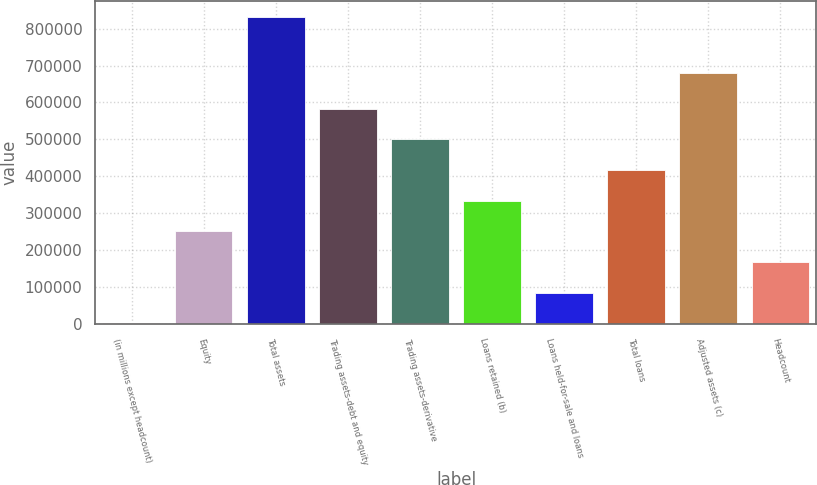Convert chart. <chart><loc_0><loc_0><loc_500><loc_500><bar_chart><fcel>(in millions except headcount)<fcel>Equity<fcel>Total assets<fcel>Trading assets-debt and equity<fcel>Trading assets-derivative<fcel>Loans retained (b)<fcel>Loans held-for-sale and loans<fcel>Total loans<fcel>Adjusted assets (c)<fcel>Headcount<nl><fcel>2008<fcel>251224<fcel>832729<fcel>583513<fcel>500441<fcel>334296<fcel>85080.1<fcel>417368<fcel>679780<fcel>168152<nl></chart> 